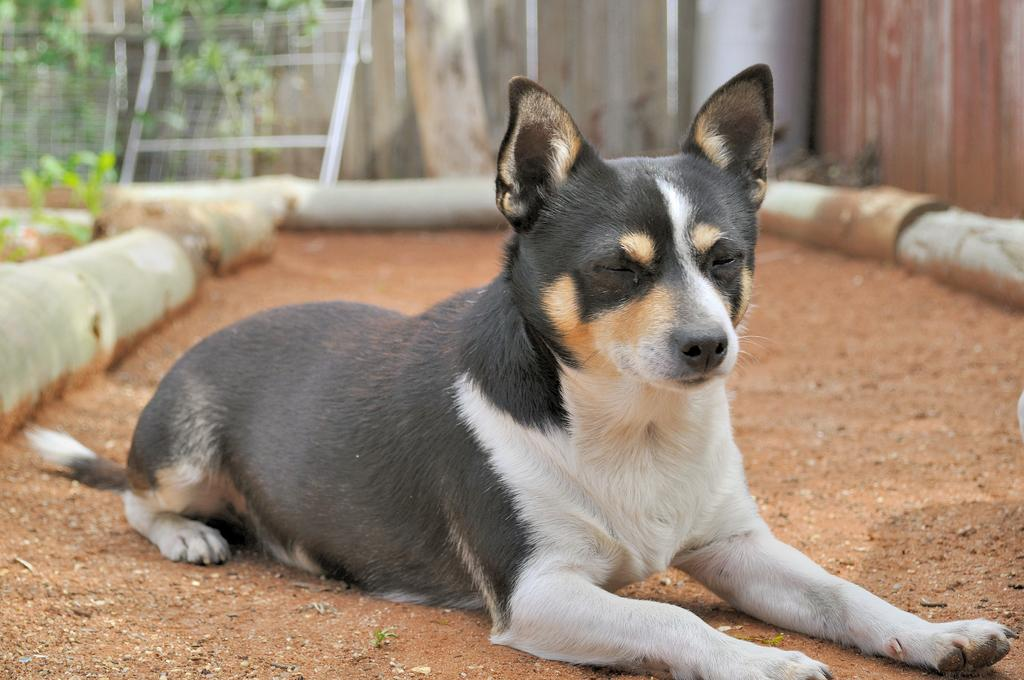What is the main subject in the center of the image? There is an animal in the center of the image. What can be seen in the background of the image? There are plants, a fence, and pipes in the background of the image. What language is the animal speaking in the image? Animals do not speak human languages, so there is no language spoken by the animal in the image. 